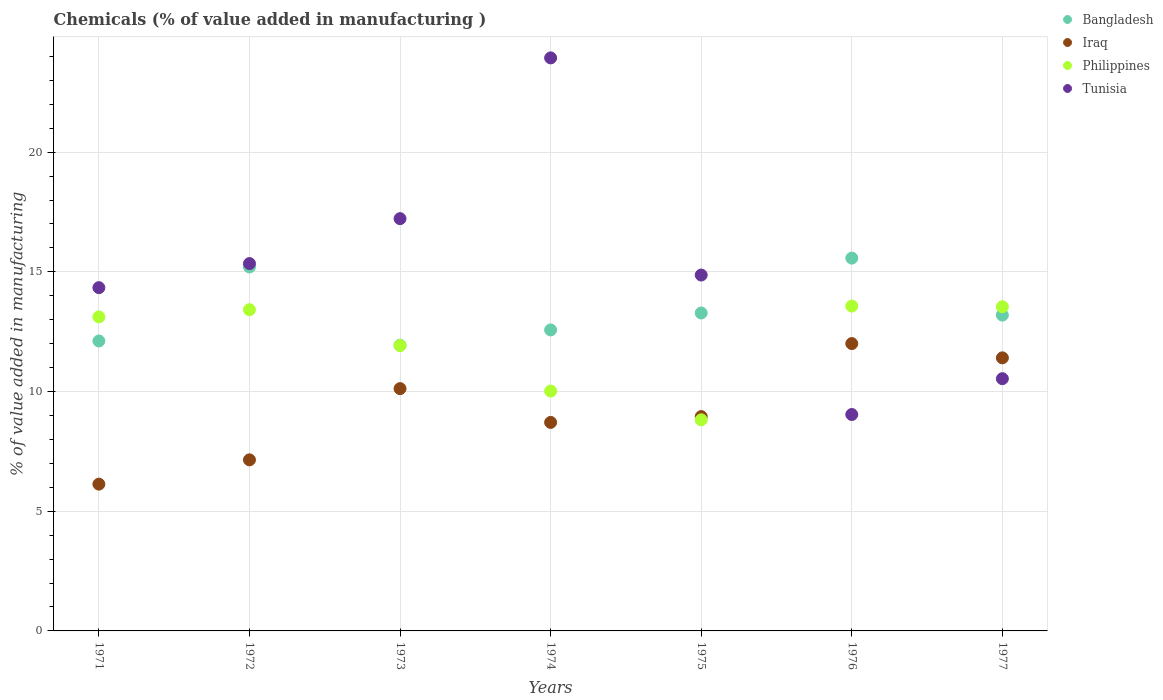How many different coloured dotlines are there?
Your answer should be compact. 4. Is the number of dotlines equal to the number of legend labels?
Your answer should be compact. Yes. What is the value added in manufacturing chemicals in Tunisia in 1972?
Offer a very short reply. 15.35. Across all years, what is the maximum value added in manufacturing chemicals in Bangladesh?
Keep it short and to the point. 15.57. Across all years, what is the minimum value added in manufacturing chemicals in Bangladesh?
Ensure brevity in your answer.  11.93. In which year was the value added in manufacturing chemicals in Philippines maximum?
Offer a terse response. 1976. In which year was the value added in manufacturing chemicals in Tunisia minimum?
Ensure brevity in your answer.  1976. What is the total value added in manufacturing chemicals in Philippines in the graph?
Provide a succinct answer. 84.41. What is the difference between the value added in manufacturing chemicals in Philippines in 1974 and that in 1975?
Keep it short and to the point. 1.2. What is the difference between the value added in manufacturing chemicals in Bangladesh in 1973 and the value added in manufacturing chemicals in Philippines in 1971?
Make the answer very short. -1.18. What is the average value added in manufacturing chemicals in Philippines per year?
Offer a very short reply. 12.06. In the year 1976, what is the difference between the value added in manufacturing chemicals in Iraq and value added in manufacturing chemicals in Philippines?
Make the answer very short. -1.57. In how many years, is the value added in manufacturing chemicals in Bangladesh greater than 16 %?
Make the answer very short. 0. What is the ratio of the value added in manufacturing chemicals in Iraq in 1973 to that in 1975?
Your response must be concise. 1.13. Is the value added in manufacturing chemicals in Bangladesh in 1975 less than that in 1976?
Your answer should be compact. Yes. Is the difference between the value added in manufacturing chemicals in Iraq in 1971 and 1972 greater than the difference between the value added in manufacturing chemicals in Philippines in 1971 and 1972?
Keep it short and to the point. No. What is the difference between the highest and the second highest value added in manufacturing chemicals in Bangladesh?
Offer a terse response. 0.37. What is the difference between the highest and the lowest value added in manufacturing chemicals in Iraq?
Offer a terse response. 5.87. Is it the case that in every year, the sum of the value added in manufacturing chemicals in Tunisia and value added in manufacturing chemicals in Bangladesh  is greater than the sum of value added in manufacturing chemicals in Philippines and value added in manufacturing chemicals in Iraq?
Your answer should be compact. No. Is it the case that in every year, the sum of the value added in manufacturing chemicals in Iraq and value added in manufacturing chemicals in Tunisia  is greater than the value added in manufacturing chemicals in Philippines?
Make the answer very short. Yes. Does the value added in manufacturing chemicals in Philippines monotonically increase over the years?
Your answer should be compact. No. How many dotlines are there?
Ensure brevity in your answer.  4. How many years are there in the graph?
Make the answer very short. 7. Are the values on the major ticks of Y-axis written in scientific E-notation?
Your response must be concise. No. Does the graph contain grids?
Provide a short and direct response. Yes. What is the title of the graph?
Give a very brief answer. Chemicals (% of value added in manufacturing ). Does "Tanzania" appear as one of the legend labels in the graph?
Make the answer very short. No. What is the label or title of the Y-axis?
Your answer should be very brief. % of value added in manufacturing. What is the % of value added in manufacturing of Bangladesh in 1971?
Ensure brevity in your answer.  12.11. What is the % of value added in manufacturing of Iraq in 1971?
Ensure brevity in your answer.  6.13. What is the % of value added in manufacturing in Philippines in 1971?
Your answer should be compact. 13.12. What is the % of value added in manufacturing in Tunisia in 1971?
Your answer should be very brief. 14.34. What is the % of value added in manufacturing in Bangladesh in 1972?
Your answer should be compact. 15.2. What is the % of value added in manufacturing in Iraq in 1972?
Ensure brevity in your answer.  7.15. What is the % of value added in manufacturing in Philippines in 1972?
Offer a terse response. 13.42. What is the % of value added in manufacturing in Tunisia in 1972?
Offer a very short reply. 15.35. What is the % of value added in manufacturing in Bangladesh in 1973?
Offer a very short reply. 11.93. What is the % of value added in manufacturing of Iraq in 1973?
Provide a short and direct response. 10.12. What is the % of value added in manufacturing in Philippines in 1973?
Ensure brevity in your answer.  11.92. What is the % of value added in manufacturing of Tunisia in 1973?
Provide a succinct answer. 17.22. What is the % of value added in manufacturing in Bangladesh in 1974?
Ensure brevity in your answer.  12.57. What is the % of value added in manufacturing in Iraq in 1974?
Make the answer very short. 8.71. What is the % of value added in manufacturing of Philippines in 1974?
Ensure brevity in your answer.  10.02. What is the % of value added in manufacturing in Tunisia in 1974?
Keep it short and to the point. 23.94. What is the % of value added in manufacturing in Bangladesh in 1975?
Provide a short and direct response. 13.28. What is the % of value added in manufacturing in Iraq in 1975?
Your response must be concise. 8.95. What is the % of value added in manufacturing of Philippines in 1975?
Give a very brief answer. 8.82. What is the % of value added in manufacturing in Tunisia in 1975?
Keep it short and to the point. 14.87. What is the % of value added in manufacturing of Bangladesh in 1976?
Offer a very short reply. 15.57. What is the % of value added in manufacturing of Iraq in 1976?
Your answer should be very brief. 12. What is the % of value added in manufacturing in Philippines in 1976?
Make the answer very short. 13.57. What is the % of value added in manufacturing of Tunisia in 1976?
Your answer should be very brief. 9.04. What is the % of value added in manufacturing of Bangladesh in 1977?
Provide a short and direct response. 13.19. What is the % of value added in manufacturing in Iraq in 1977?
Your response must be concise. 11.41. What is the % of value added in manufacturing in Philippines in 1977?
Your answer should be very brief. 13.54. What is the % of value added in manufacturing in Tunisia in 1977?
Your answer should be compact. 10.54. Across all years, what is the maximum % of value added in manufacturing of Bangladesh?
Your answer should be very brief. 15.57. Across all years, what is the maximum % of value added in manufacturing of Iraq?
Give a very brief answer. 12. Across all years, what is the maximum % of value added in manufacturing of Philippines?
Provide a succinct answer. 13.57. Across all years, what is the maximum % of value added in manufacturing in Tunisia?
Give a very brief answer. 23.94. Across all years, what is the minimum % of value added in manufacturing of Bangladesh?
Give a very brief answer. 11.93. Across all years, what is the minimum % of value added in manufacturing in Iraq?
Your response must be concise. 6.13. Across all years, what is the minimum % of value added in manufacturing in Philippines?
Offer a very short reply. 8.82. Across all years, what is the minimum % of value added in manufacturing of Tunisia?
Your answer should be very brief. 9.04. What is the total % of value added in manufacturing of Bangladesh in the graph?
Make the answer very short. 93.88. What is the total % of value added in manufacturing in Iraq in the graph?
Your answer should be compact. 64.48. What is the total % of value added in manufacturing of Philippines in the graph?
Provide a succinct answer. 84.41. What is the total % of value added in manufacturing in Tunisia in the graph?
Offer a terse response. 105.29. What is the difference between the % of value added in manufacturing in Bangladesh in 1971 and that in 1972?
Your answer should be compact. -3.09. What is the difference between the % of value added in manufacturing in Iraq in 1971 and that in 1972?
Offer a very short reply. -1.01. What is the difference between the % of value added in manufacturing of Philippines in 1971 and that in 1972?
Ensure brevity in your answer.  -0.3. What is the difference between the % of value added in manufacturing in Tunisia in 1971 and that in 1972?
Give a very brief answer. -1.01. What is the difference between the % of value added in manufacturing in Bangladesh in 1971 and that in 1973?
Your answer should be compact. 0.18. What is the difference between the % of value added in manufacturing of Iraq in 1971 and that in 1973?
Your response must be concise. -3.99. What is the difference between the % of value added in manufacturing of Philippines in 1971 and that in 1973?
Your answer should be compact. 1.2. What is the difference between the % of value added in manufacturing in Tunisia in 1971 and that in 1973?
Your answer should be compact. -2.88. What is the difference between the % of value added in manufacturing of Bangladesh in 1971 and that in 1974?
Your response must be concise. -0.46. What is the difference between the % of value added in manufacturing in Iraq in 1971 and that in 1974?
Make the answer very short. -2.58. What is the difference between the % of value added in manufacturing of Philippines in 1971 and that in 1974?
Offer a very short reply. 3.1. What is the difference between the % of value added in manufacturing of Tunisia in 1971 and that in 1974?
Make the answer very short. -9.6. What is the difference between the % of value added in manufacturing of Bangladesh in 1971 and that in 1975?
Provide a short and direct response. -1.17. What is the difference between the % of value added in manufacturing in Iraq in 1971 and that in 1975?
Keep it short and to the point. -2.82. What is the difference between the % of value added in manufacturing of Philippines in 1971 and that in 1975?
Offer a very short reply. 4.3. What is the difference between the % of value added in manufacturing of Tunisia in 1971 and that in 1975?
Keep it short and to the point. -0.53. What is the difference between the % of value added in manufacturing of Bangladesh in 1971 and that in 1976?
Your answer should be very brief. -3.46. What is the difference between the % of value added in manufacturing of Iraq in 1971 and that in 1976?
Provide a short and direct response. -5.87. What is the difference between the % of value added in manufacturing of Philippines in 1971 and that in 1976?
Provide a short and direct response. -0.45. What is the difference between the % of value added in manufacturing in Tunisia in 1971 and that in 1976?
Offer a terse response. 5.3. What is the difference between the % of value added in manufacturing of Bangladesh in 1971 and that in 1977?
Your response must be concise. -1.08. What is the difference between the % of value added in manufacturing of Iraq in 1971 and that in 1977?
Your answer should be very brief. -5.28. What is the difference between the % of value added in manufacturing in Philippines in 1971 and that in 1977?
Make the answer very short. -0.42. What is the difference between the % of value added in manufacturing of Tunisia in 1971 and that in 1977?
Give a very brief answer. 3.8. What is the difference between the % of value added in manufacturing of Bangladesh in 1972 and that in 1973?
Ensure brevity in your answer.  3.27. What is the difference between the % of value added in manufacturing of Iraq in 1972 and that in 1973?
Provide a short and direct response. -2.98. What is the difference between the % of value added in manufacturing in Philippines in 1972 and that in 1973?
Provide a short and direct response. 1.5. What is the difference between the % of value added in manufacturing of Tunisia in 1972 and that in 1973?
Provide a short and direct response. -1.88. What is the difference between the % of value added in manufacturing of Bangladesh in 1972 and that in 1974?
Keep it short and to the point. 2.63. What is the difference between the % of value added in manufacturing of Iraq in 1972 and that in 1974?
Keep it short and to the point. -1.56. What is the difference between the % of value added in manufacturing in Philippines in 1972 and that in 1974?
Provide a short and direct response. 3.4. What is the difference between the % of value added in manufacturing in Tunisia in 1972 and that in 1974?
Give a very brief answer. -8.59. What is the difference between the % of value added in manufacturing in Bangladesh in 1972 and that in 1975?
Your answer should be compact. 1.92. What is the difference between the % of value added in manufacturing in Iraq in 1972 and that in 1975?
Ensure brevity in your answer.  -1.81. What is the difference between the % of value added in manufacturing in Philippines in 1972 and that in 1975?
Your answer should be very brief. 4.6. What is the difference between the % of value added in manufacturing in Tunisia in 1972 and that in 1975?
Ensure brevity in your answer.  0.48. What is the difference between the % of value added in manufacturing in Bangladesh in 1972 and that in 1976?
Your answer should be very brief. -0.37. What is the difference between the % of value added in manufacturing of Iraq in 1972 and that in 1976?
Offer a terse response. -4.86. What is the difference between the % of value added in manufacturing of Philippines in 1972 and that in 1976?
Provide a succinct answer. -0.15. What is the difference between the % of value added in manufacturing in Tunisia in 1972 and that in 1976?
Offer a very short reply. 6.31. What is the difference between the % of value added in manufacturing of Bangladesh in 1972 and that in 1977?
Make the answer very short. 2.01. What is the difference between the % of value added in manufacturing in Iraq in 1972 and that in 1977?
Offer a terse response. -4.26. What is the difference between the % of value added in manufacturing in Philippines in 1972 and that in 1977?
Your answer should be compact. -0.12. What is the difference between the % of value added in manufacturing in Tunisia in 1972 and that in 1977?
Offer a terse response. 4.81. What is the difference between the % of value added in manufacturing of Bangladesh in 1973 and that in 1974?
Offer a very short reply. -0.64. What is the difference between the % of value added in manufacturing in Iraq in 1973 and that in 1974?
Your response must be concise. 1.41. What is the difference between the % of value added in manufacturing in Philippines in 1973 and that in 1974?
Make the answer very short. 1.9. What is the difference between the % of value added in manufacturing of Tunisia in 1973 and that in 1974?
Provide a short and direct response. -6.72. What is the difference between the % of value added in manufacturing in Bangladesh in 1973 and that in 1975?
Your answer should be very brief. -1.35. What is the difference between the % of value added in manufacturing in Iraq in 1973 and that in 1975?
Offer a very short reply. 1.17. What is the difference between the % of value added in manufacturing of Philippines in 1973 and that in 1975?
Provide a succinct answer. 3.1. What is the difference between the % of value added in manufacturing of Tunisia in 1973 and that in 1975?
Make the answer very short. 2.36. What is the difference between the % of value added in manufacturing in Bangladesh in 1973 and that in 1976?
Provide a succinct answer. -3.64. What is the difference between the % of value added in manufacturing in Iraq in 1973 and that in 1976?
Give a very brief answer. -1.88. What is the difference between the % of value added in manufacturing in Philippines in 1973 and that in 1976?
Keep it short and to the point. -1.65. What is the difference between the % of value added in manufacturing of Tunisia in 1973 and that in 1976?
Ensure brevity in your answer.  8.18. What is the difference between the % of value added in manufacturing of Bangladesh in 1973 and that in 1977?
Offer a very short reply. -1.26. What is the difference between the % of value added in manufacturing in Iraq in 1973 and that in 1977?
Your response must be concise. -1.29. What is the difference between the % of value added in manufacturing of Philippines in 1973 and that in 1977?
Your answer should be compact. -1.62. What is the difference between the % of value added in manufacturing in Tunisia in 1973 and that in 1977?
Your answer should be compact. 6.69. What is the difference between the % of value added in manufacturing of Bangladesh in 1974 and that in 1975?
Your answer should be compact. -0.71. What is the difference between the % of value added in manufacturing of Iraq in 1974 and that in 1975?
Ensure brevity in your answer.  -0.24. What is the difference between the % of value added in manufacturing in Philippines in 1974 and that in 1975?
Provide a succinct answer. 1.2. What is the difference between the % of value added in manufacturing in Tunisia in 1974 and that in 1975?
Give a very brief answer. 9.07. What is the difference between the % of value added in manufacturing in Bangladesh in 1974 and that in 1976?
Make the answer very short. -3. What is the difference between the % of value added in manufacturing in Iraq in 1974 and that in 1976?
Offer a very short reply. -3.29. What is the difference between the % of value added in manufacturing in Philippines in 1974 and that in 1976?
Your answer should be compact. -3.55. What is the difference between the % of value added in manufacturing of Tunisia in 1974 and that in 1976?
Ensure brevity in your answer.  14.9. What is the difference between the % of value added in manufacturing of Bangladesh in 1974 and that in 1977?
Keep it short and to the point. -0.62. What is the difference between the % of value added in manufacturing of Iraq in 1974 and that in 1977?
Provide a succinct answer. -2.7. What is the difference between the % of value added in manufacturing in Philippines in 1974 and that in 1977?
Keep it short and to the point. -3.52. What is the difference between the % of value added in manufacturing in Tunisia in 1974 and that in 1977?
Provide a succinct answer. 13.4. What is the difference between the % of value added in manufacturing in Bangladesh in 1975 and that in 1976?
Give a very brief answer. -2.29. What is the difference between the % of value added in manufacturing of Iraq in 1975 and that in 1976?
Ensure brevity in your answer.  -3.05. What is the difference between the % of value added in manufacturing of Philippines in 1975 and that in 1976?
Provide a short and direct response. -4.75. What is the difference between the % of value added in manufacturing of Tunisia in 1975 and that in 1976?
Offer a very short reply. 5.83. What is the difference between the % of value added in manufacturing in Bangladesh in 1975 and that in 1977?
Offer a very short reply. 0.09. What is the difference between the % of value added in manufacturing in Iraq in 1975 and that in 1977?
Provide a succinct answer. -2.45. What is the difference between the % of value added in manufacturing of Philippines in 1975 and that in 1977?
Keep it short and to the point. -4.72. What is the difference between the % of value added in manufacturing of Tunisia in 1975 and that in 1977?
Keep it short and to the point. 4.33. What is the difference between the % of value added in manufacturing in Bangladesh in 1976 and that in 1977?
Your response must be concise. 2.38. What is the difference between the % of value added in manufacturing in Iraq in 1976 and that in 1977?
Ensure brevity in your answer.  0.6. What is the difference between the % of value added in manufacturing in Philippines in 1976 and that in 1977?
Your answer should be very brief. 0.03. What is the difference between the % of value added in manufacturing of Tunisia in 1976 and that in 1977?
Ensure brevity in your answer.  -1.5. What is the difference between the % of value added in manufacturing of Bangladesh in 1971 and the % of value added in manufacturing of Iraq in 1972?
Your response must be concise. 4.97. What is the difference between the % of value added in manufacturing in Bangladesh in 1971 and the % of value added in manufacturing in Philippines in 1972?
Make the answer very short. -1.31. What is the difference between the % of value added in manufacturing in Bangladesh in 1971 and the % of value added in manufacturing in Tunisia in 1972?
Your response must be concise. -3.24. What is the difference between the % of value added in manufacturing in Iraq in 1971 and the % of value added in manufacturing in Philippines in 1972?
Provide a short and direct response. -7.29. What is the difference between the % of value added in manufacturing of Iraq in 1971 and the % of value added in manufacturing of Tunisia in 1972?
Your answer should be compact. -9.22. What is the difference between the % of value added in manufacturing in Philippines in 1971 and the % of value added in manufacturing in Tunisia in 1972?
Your answer should be very brief. -2.23. What is the difference between the % of value added in manufacturing of Bangladesh in 1971 and the % of value added in manufacturing of Iraq in 1973?
Keep it short and to the point. 1.99. What is the difference between the % of value added in manufacturing of Bangladesh in 1971 and the % of value added in manufacturing of Philippines in 1973?
Ensure brevity in your answer.  0.19. What is the difference between the % of value added in manufacturing in Bangladesh in 1971 and the % of value added in manufacturing in Tunisia in 1973?
Ensure brevity in your answer.  -5.11. What is the difference between the % of value added in manufacturing of Iraq in 1971 and the % of value added in manufacturing of Philippines in 1973?
Make the answer very short. -5.79. What is the difference between the % of value added in manufacturing of Iraq in 1971 and the % of value added in manufacturing of Tunisia in 1973?
Offer a very short reply. -11.09. What is the difference between the % of value added in manufacturing of Philippines in 1971 and the % of value added in manufacturing of Tunisia in 1973?
Give a very brief answer. -4.1. What is the difference between the % of value added in manufacturing in Bangladesh in 1971 and the % of value added in manufacturing in Iraq in 1974?
Your answer should be very brief. 3.4. What is the difference between the % of value added in manufacturing of Bangladesh in 1971 and the % of value added in manufacturing of Philippines in 1974?
Offer a very short reply. 2.09. What is the difference between the % of value added in manufacturing of Bangladesh in 1971 and the % of value added in manufacturing of Tunisia in 1974?
Make the answer very short. -11.83. What is the difference between the % of value added in manufacturing of Iraq in 1971 and the % of value added in manufacturing of Philippines in 1974?
Your answer should be compact. -3.89. What is the difference between the % of value added in manufacturing in Iraq in 1971 and the % of value added in manufacturing in Tunisia in 1974?
Your response must be concise. -17.81. What is the difference between the % of value added in manufacturing of Philippines in 1971 and the % of value added in manufacturing of Tunisia in 1974?
Your answer should be compact. -10.82. What is the difference between the % of value added in manufacturing of Bangladesh in 1971 and the % of value added in manufacturing of Iraq in 1975?
Offer a terse response. 3.16. What is the difference between the % of value added in manufacturing in Bangladesh in 1971 and the % of value added in manufacturing in Philippines in 1975?
Offer a very short reply. 3.29. What is the difference between the % of value added in manufacturing of Bangladesh in 1971 and the % of value added in manufacturing of Tunisia in 1975?
Your response must be concise. -2.75. What is the difference between the % of value added in manufacturing of Iraq in 1971 and the % of value added in manufacturing of Philippines in 1975?
Your answer should be very brief. -2.69. What is the difference between the % of value added in manufacturing of Iraq in 1971 and the % of value added in manufacturing of Tunisia in 1975?
Provide a short and direct response. -8.73. What is the difference between the % of value added in manufacturing in Philippines in 1971 and the % of value added in manufacturing in Tunisia in 1975?
Your answer should be very brief. -1.75. What is the difference between the % of value added in manufacturing in Bangladesh in 1971 and the % of value added in manufacturing in Iraq in 1976?
Your response must be concise. 0.11. What is the difference between the % of value added in manufacturing of Bangladesh in 1971 and the % of value added in manufacturing of Philippines in 1976?
Make the answer very short. -1.46. What is the difference between the % of value added in manufacturing in Bangladesh in 1971 and the % of value added in manufacturing in Tunisia in 1976?
Ensure brevity in your answer.  3.07. What is the difference between the % of value added in manufacturing of Iraq in 1971 and the % of value added in manufacturing of Philippines in 1976?
Your response must be concise. -7.44. What is the difference between the % of value added in manufacturing of Iraq in 1971 and the % of value added in manufacturing of Tunisia in 1976?
Provide a short and direct response. -2.91. What is the difference between the % of value added in manufacturing of Philippines in 1971 and the % of value added in manufacturing of Tunisia in 1976?
Provide a succinct answer. 4.08. What is the difference between the % of value added in manufacturing in Bangladesh in 1971 and the % of value added in manufacturing in Iraq in 1977?
Give a very brief answer. 0.7. What is the difference between the % of value added in manufacturing in Bangladesh in 1971 and the % of value added in manufacturing in Philippines in 1977?
Your response must be concise. -1.43. What is the difference between the % of value added in manufacturing of Bangladesh in 1971 and the % of value added in manufacturing of Tunisia in 1977?
Offer a terse response. 1.58. What is the difference between the % of value added in manufacturing of Iraq in 1971 and the % of value added in manufacturing of Philippines in 1977?
Give a very brief answer. -7.41. What is the difference between the % of value added in manufacturing of Iraq in 1971 and the % of value added in manufacturing of Tunisia in 1977?
Your response must be concise. -4.4. What is the difference between the % of value added in manufacturing in Philippines in 1971 and the % of value added in manufacturing in Tunisia in 1977?
Make the answer very short. 2.58. What is the difference between the % of value added in manufacturing in Bangladesh in 1972 and the % of value added in manufacturing in Iraq in 1973?
Ensure brevity in your answer.  5.08. What is the difference between the % of value added in manufacturing of Bangladesh in 1972 and the % of value added in manufacturing of Philippines in 1973?
Give a very brief answer. 3.29. What is the difference between the % of value added in manufacturing in Bangladesh in 1972 and the % of value added in manufacturing in Tunisia in 1973?
Your answer should be very brief. -2.02. What is the difference between the % of value added in manufacturing in Iraq in 1972 and the % of value added in manufacturing in Philippines in 1973?
Keep it short and to the point. -4.77. What is the difference between the % of value added in manufacturing of Iraq in 1972 and the % of value added in manufacturing of Tunisia in 1973?
Provide a succinct answer. -10.08. What is the difference between the % of value added in manufacturing of Philippines in 1972 and the % of value added in manufacturing of Tunisia in 1973?
Keep it short and to the point. -3.8. What is the difference between the % of value added in manufacturing of Bangladesh in 1972 and the % of value added in manufacturing of Iraq in 1974?
Keep it short and to the point. 6.49. What is the difference between the % of value added in manufacturing in Bangladesh in 1972 and the % of value added in manufacturing in Philippines in 1974?
Provide a succinct answer. 5.18. What is the difference between the % of value added in manufacturing in Bangladesh in 1972 and the % of value added in manufacturing in Tunisia in 1974?
Give a very brief answer. -8.73. What is the difference between the % of value added in manufacturing of Iraq in 1972 and the % of value added in manufacturing of Philippines in 1974?
Your answer should be compact. -2.87. What is the difference between the % of value added in manufacturing of Iraq in 1972 and the % of value added in manufacturing of Tunisia in 1974?
Your answer should be compact. -16.79. What is the difference between the % of value added in manufacturing of Philippines in 1972 and the % of value added in manufacturing of Tunisia in 1974?
Give a very brief answer. -10.52. What is the difference between the % of value added in manufacturing of Bangladesh in 1972 and the % of value added in manufacturing of Iraq in 1975?
Your answer should be very brief. 6.25. What is the difference between the % of value added in manufacturing in Bangladesh in 1972 and the % of value added in manufacturing in Philippines in 1975?
Provide a succinct answer. 6.39. What is the difference between the % of value added in manufacturing in Bangladesh in 1972 and the % of value added in manufacturing in Tunisia in 1975?
Provide a short and direct response. 0.34. What is the difference between the % of value added in manufacturing in Iraq in 1972 and the % of value added in manufacturing in Philippines in 1975?
Your answer should be compact. -1.67. What is the difference between the % of value added in manufacturing in Iraq in 1972 and the % of value added in manufacturing in Tunisia in 1975?
Your response must be concise. -7.72. What is the difference between the % of value added in manufacturing of Philippines in 1972 and the % of value added in manufacturing of Tunisia in 1975?
Your answer should be compact. -1.45. What is the difference between the % of value added in manufacturing in Bangladesh in 1972 and the % of value added in manufacturing in Iraq in 1976?
Make the answer very short. 3.2. What is the difference between the % of value added in manufacturing in Bangladesh in 1972 and the % of value added in manufacturing in Philippines in 1976?
Give a very brief answer. 1.63. What is the difference between the % of value added in manufacturing in Bangladesh in 1972 and the % of value added in manufacturing in Tunisia in 1976?
Give a very brief answer. 6.16. What is the difference between the % of value added in manufacturing of Iraq in 1972 and the % of value added in manufacturing of Philippines in 1976?
Offer a very short reply. -6.42. What is the difference between the % of value added in manufacturing of Iraq in 1972 and the % of value added in manufacturing of Tunisia in 1976?
Provide a succinct answer. -1.89. What is the difference between the % of value added in manufacturing in Philippines in 1972 and the % of value added in manufacturing in Tunisia in 1976?
Keep it short and to the point. 4.38. What is the difference between the % of value added in manufacturing in Bangladesh in 1972 and the % of value added in manufacturing in Iraq in 1977?
Provide a short and direct response. 3.8. What is the difference between the % of value added in manufacturing in Bangladesh in 1972 and the % of value added in manufacturing in Philippines in 1977?
Give a very brief answer. 1.66. What is the difference between the % of value added in manufacturing in Bangladesh in 1972 and the % of value added in manufacturing in Tunisia in 1977?
Your answer should be very brief. 4.67. What is the difference between the % of value added in manufacturing in Iraq in 1972 and the % of value added in manufacturing in Philippines in 1977?
Provide a succinct answer. -6.4. What is the difference between the % of value added in manufacturing in Iraq in 1972 and the % of value added in manufacturing in Tunisia in 1977?
Ensure brevity in your answer.  -3.39. What is the difference between the % of value added in manufacturing of Philippines in 1972 and the % of value added in manufacturing of Tunisia in 1977?
Provide a short and direct response. 2.88. What is the difference between the % of value added in manufacturing of Bangladesh in 1973 and the % of value added in manufacturing of Iraq in 1974?
Give a very brief answer. 3.22. What is the difference between the % of value added in manufacturing of Bangladesh in 1973 and the % of value added in manufacturing of Philippines in 1974?
Your answer should be compact. 1.91. What is the difference between the % of value added in manufacturing of Bangladesh in 1973 and the % of value added in manufacturing of Tunisia in 1974?
Your response must be concise. -12. What is the difference between the % of value added in manufacturing of Iraq in 1973 and the % of value added in manufacturing of Philippines in 1974?
Offer a terse response. 0.1. What is the difference between the % of value added in manufacturing in Iraq in 1973 and the % of value added in manufacturing in Tunisia in 1974?
Keep it short and to the point. -13.82. What is the difference between the % of value added in manufacturing in Philippines in 1973 and the % of value added in manufacturing in Tunisia in 1974?
Make the answer very short. -12.02. What is the difference between the % of value added in manufacturing in Bangladesh in 1973 and the % of value added in manufacturing in Iraq in 1975?
Provide a short and direct response. 2.98. What is the difference between the % of value added in manufacturing of Bangladesh in 1973 and the % of value added in manufacturing of Philippines in 1975?
Provide a succinct answer. 3.12. What is the difference between the % of value added in manufacturing in Bangladesh in 1973 and the % of value added in manufacturing in Tunisia in 1975?
Ensure brevity in your answer.  -2.93. What is the difference between the % of value added in manufacturing in Iraq in 1973 and the % of value added in manufacturing in Philippines in 1975?
Ensure brevity in your answer.  1.3. What is the difference between the % of value added in manufacturing of Iraq in 1973 and the % of value added in manufacturing of Tunisia in 1975?
Give a very brief answer. -4.74. What is the difference between the % of value added in manufacturing in Philippines in 1973 and the % of value added in manufacturing in Tunisia in 1975?
Your answer should be compact. -2.95. What is the difference between the % of value added in manufacturing in Bangladesh in 1973 and the % of value added in manufacturing in Iraq in 1976?
Offer a very short reply. -0.07. What is the difference between the % of value added in manufacturing in Bangladesh in 1973 and the % of value added in manufacturing in Philippines in 1976?
Give a very brief answer. -1.64. What is the difference between the % of value added in manufacturing of Bangladesh in 1973 and the % of value added in manufacturing of Tunisia in 1976?
Your answer should be compact. 2.89. What is the difference between the % of value added in manufacturing of Iraq in 1973 and the % of value added in manufacturing of Philippines in 1976?
Keep it short and to the point. -3.45. What is the difference between the % of value added in manufacturing in Iraq in 1973 and the % of value added in manufacturing in Tunisia in 1976?
Your answer should be very brief. 1.08. What is the difference between the % of value added in manufacturing in Philippines in 1973 and the % of value added in manufacturing in Tunisia in 1976?
Your answer should be compact. 2.88. What is the difference between the % of value added in manufacturing of Bangladesh in 1973 and the % of value added in manufacturing of Iraq in 1977?
Make the answer very short. 0.53. What is the difference between the % of value added in manufacturing of Bangladesh in 1973 and the % of value added in manufacturing of Philippines in 1977?
Offer a very short reply. -1.61. What is the difference between the % of value added in manufacturing of Bangladesh in 1973 and the % of value added in manufacturing of Tunisia in 1977?
Offer a very short reply. 1.4. What is the difference between the % of value added in manufacturing of Iraq in 1973 and the % of value added in manufacturing of Philippines in 1977?
Offer a terse response. -3.42. What is the difference between the % of value added in manufacturing of Iraq in 1973 and the % of value added in manufacturing of Tunisia in 1977?
Make the answer very short. -0.41. What is the difference between the % of value added in manufacturing in Philippines in 1973 and the % of value added in manufacturing in Tunisia in 1977?
Your answer should be compact. 1.38. What is the difference between the % of value added in manufacturing of Bangladesh in 1974 and the % of value added in manufacturing of Iraq in 1975?
Your response must be concise. 3.62. What is the difference between the % of value added in manufacturing of Bangladesh in 1974 and the % of value added in manufacturing of Philippines in 1975?
Ensure brevity in your answer.  3.76. What is the difference between the % of value added in manufacturing of Bangladesh in 1974 and the % of value added in manufacturing of Tunisia in 1975?
Ensure brevity in your answer.  -2.29. What is the difference between the % of value added in manufacturing of Iraq in 1974 and the % of value added in manufacturing of Philippines in 1975?
Your response must be concise. -0.11. What is the difference between the % of value added in manufacturing in Iraq in 1974 and the % of value added in manufacturing in Tunisia in 1975?
Your answer should be very brief. -6.16. What is the difference between the % of value added in manufacturing of Philippines in 1974 and the % of value added in manufacturing of Tunisia in 1975?
Offer a terse response. -4.85. What is the difference between the % of value added in manufacturing in Bangladesh in 1974 and the % of value added in manufacturing in Iraq in 1976?
Your answer should be very brief. 0.57. What is the difference between the % of value added in manufacturing in Bangladesh in 1974 and the % of value added in manufacturing in Philippines in 1976?
Your answer should be very brief. -1. What is the difference between the % of value added in manufacturing in Bangladesh in 1974 and the % of value added in manufacturing in Tunisia in 1976?
Make the answer very short. 3.53. What is the difference between the % of value added in manufacturing of Iraq in 1974 and the % of value added in manufacturing of Philippines in 1976?
Ensure brevity in your answer.  -4.86. What is the difference between the % of value added in manufacturing of Iraq in 1974 and the % of value added in manufacturing of Tunisia in 1976?
Provide a succinct answer. -0.33. What is the difference between the % of value added in manufacturing in Philippines in 1974 and the % of value added in manufacturing in Tunisia in 1976?
Your answer should be compact. 0.98. What is the difference between the % of value added in manufacturing in Bangladesh in 1974 and the % of value added in manufacturing in Iraq in 1977?
Offer a very short reply. 1.17. What is the difference between the % of value added in manufacturing of Bangladesh in 1974 and the % of value added in manufacturing of Philippines in 1977?
Offer a very short reply. -0.97. What is the difference between the % of value added in manufacturing of Bangladesh in 1974 and the % of value added in manufacturing of Tunisia in 1977?
Offer a very short reply. 2.04. What is the difference between the % of value added in manufacturing in Iraq in 1974 and the % of value added in manufacturing in Philippines in 1977?
Make the answer very short. -4.83. What is the difference between the % of value added in manufacturing in Iraq in 1974 and the % of value added in manufacturing in Tunisia in 1977?
Give a very brief answer. -1.83. What is the difference between the % of value added in manufacturing of Philippines in 1974 and the % of value added in manufacturing of Tunisia in 1977?
Give a very brief answer. -0.52. What is the difference between the % of value added in manufacturing of Bangladesh in 1975 and the % of value added in manufacturing of Iraq in 1976?
Offer a very short reply. 1.28. What is the difference between the % of value added in manufacturing in Bangladesh in 1975 and the % of value added in manufacturing in Philippines in 1976?
Provide a short and direct response. -0.29. What is the difference between the % of value added in manufacturing of Bangladesh in 1975 and the % of value added in manufacturing of Tunisia in 1976?
Make the answer very short. 4.24. What is the difference between the % of value added in manufacturing in Iraq in 1975 and the % of value added in manufacturing in Philippines in 1976?
Offer a terse response. -4.62. What is the difference between the % of value added in manufacturing in Iraq in 1975 and the % of value added in manufacturing in Tunisia in 1976?
Offer a terse response. -0.09. What is the difference between the % of value added in manufacturing of Philippines in 1975 and the % of value added in manufacturing of Tunisia in 1976?
Offer a terse response. -0.22. What is the difference between the % of value added in manufacturing in Bangladesh in 1975 and the % of value added in manufacturing in Iraq in 1977?
Your response must be concise. 1.87. What is the difference between the % of value added in manufacturing in Bangladesh in 1975 and the % of value added in manufacturing in Philippines in 1977?
Offer a very short reply. -0.26. What is the difference between the % of value added in manufacturing in Bangladesh in 1975 and the % of value added in manufacturing in Tunisia in 1977?
Offer a terse response. 2.74. What is the difference between the % of value added in manufacturing in Iraq in 1975 and the % of value added in manufacturing in Philippines in 1977?
Ensure brevity in your answer.  -4.59. What is the difference between the % of value added in manufacturing of Iraq in 1975 and the % of value added in manufacturing of Tunisia in 1977?
Offer a terse response. -1.58. What is the difference between the % of value added in manufacturing of Philippines in 1975 and the % of value added in manufacturing of Tunisia in 1977?
Offer a terse response. -1.72. What is the difference between the % of value added in manufacturing in Bangladesh in 1976 and the % of value added in manufacturing in Iraq in 1977?
Ensure brevity in your answer.  4.17. What is the difference between the % of value added in manufacturing of Bangladesh in 1976 and the % of value added in manufacturing of Philippines in 1977?
Offer a terse response. 2.03. What is the difference between the % of value added in manufacturing of Bangladesh in 1976 and the % of value added in manufacturing of Tunisia in 1977?
Provide a succinct answer. 5.04. What is the difference between the % of value added in manufacturing in Iraq in 1976 and the % of value added in manufacturing in Philippines in 1977?
Ensure brevity in your answer.  -1.54. What is the difference between the % of value added in manufacturing of Iraq in 1976 and the % of value added in manufacturing of Tunisia in 1977?
Provide a succinct answer. 1.47. What is the difference between the % of value added in manufacturing of Philippines in 1976 and the % of value added in manufacturing of Tunisia in 1977?
Offer a terse response. 3.03. What is the average % of value added in manufacturing in Bangladesh per year?
Ensure brevity in your answer.  13.41. What is the average % of value added in manufacturing in Iraq per year?
Offer a terse response. 9.21. What is the average % of value added in manufacturing of Philippines per year?
Keep it short and to the point. 12.06. What is the average % of value added in manufacturing in Tunisia per year?
Ensure brevity in your answer.  15.04. In the year 1971, what is the difference between the % of value added in manufacturing of Bangladesh and % of value added in manufacturing of Iraq?
Give a very brief answer. 5.98. In the year 1971, what is the difference between the % of value added in manufacturing of Bangladesh and % of value added in manufacturing of Philippines?
Provide a short and direct response. -1.01. In the year 1971, what is the difference between the % of value added in manufacturing in Bangladesh and % of value added in manufacturing in Tunisia?
Offer a very short reply. -2.23. In the year 1971, what is the difference between the % of value added in manufacturing of Iraq and % of value added in manufacturing of Philippines?
Your answer should be very brief. -6.99. In the year 1971, what is the difference between the % of value added in manufacturing in Iraq and % of value added in manufacturing in Tunisia?
Offer a very short reply. -8.21. In the year 1971, what is the difference between the % of value added in manufacturing in Philippines and % of value added in manufacturing in Tunisia?
Your answer should be compact. -1.22. In the year 1972, what is the difference between the % of value added in manufacturing of Bangladesh and % of value added in manufacturing of Iraq?
Offer a terse response. 8.06. In the year 1972, what is the difference between the % of value added in manufacturing of Bangladesh and % of value added in manufacturing of Philippines?
Your response must be concise. 1.79. In the year 1972, what is the difference between the % of value added in manufacturing in Bangladesh and % of value added in manufacturing in Tunisia?
Provide a succinct answer. -0.14. In the year 1972, what is the difference between the % of value added in manufacturing of Iraq and % of value added in manufacturing of Philippines?
Give a very brief answer. -6.27. In the year 1972, what is the difference between the % of value added in manufacturing in Iraq and % of value added in manufacturing in Tunisia?
Provide a succinct answer. -8.2. In the year 1972, what is the difference between the % of value added in manufacturing of Philippines and % of value added in manufacturing of Tunisia?
Provide a succinct answer. -1.93. In the year 1973, what is the difference between the % of value added in manufacturing of Bangladesh and % of value added in manufacturing of Iraq?
Offer a terse response. 1.81. In the year 1973, what is the difference between the % of value added in manufacturing in Bangladesh and % of value added in manufacturing in Philippines?
Ensure brevity in your answer.  0.01. In the year 1973, what is the difference between the % of value added in manufacturing of Bangladesh and % of value added in manufacturing of Tunisia?
Your answer should be compact. -5.29. In the year 1973, what is the difference between the % of value added in manufacturing of Iraq and % of value added in manufacturing of Philippines?
Offer a very short reply. -1.8. In the year 1973, what is the difference between the % of value added in manufacturing of Iraq and % of value added in manufacturing of Tunisia?
Give a very brief answer. -7.1. In the year 1973, what is the difference between the % of value added in manufacturing of Philippines and % of value added in manufacturing of Tunisia?
Keep it short and to the point. -5.3. In the year 1974, what is the difference between the % of value added in manufacturing in Bangladesh and % of value added in manufacturing in Iraq?
Provide a short and direct response. 3.86. In the year 1974, what is the difference between the % of value added in manufacturing in Bangladesh and % of value added in manufacturing in Philippines?
Make the answer very short. 2.55. In the year 1974, what is the difference between the % of value added in manufacturing in Bangladesh and % of value added in manufacturing in Tunisia?
Your response must be concise. -11.36. In the year 1974, what is the difference between the % of value added in manufacturing in Iraq and % of value added in manufacturing in Philippines?
Make the answer very short. -1.31. In the year 1974, what is the difference between the % of value added in manufacturing of Iraq and % of value added in manufacturing of Tunisia?
Make the answer very short. -15.23. In the year 1974, what is the difference between the % of value added in manufacturing in Philippines and % of value added in manufacturing in Tunisia?
Offer a very short reply. -13.92. In the year 1975, what is the difference between the % of value added in manufacturing in Bangladesh and % of value added in manufacturing in Iraq?
Your answer should be very brief. 4.33. In the year 1975, what is the difference between the % of value added in manufacturing of Bangladesh and % of value added in manufacturing of Philippines?
Make the answer very short. 4.46. In the year 1975, what is the difference between the % of value added in manufacturing of Bangladesh and % of value added in manufacturing of Tunisia?
Your answer should be compact. -1.59. In the year 1975, what is the difference between the % of value added in manufacturing in Iraq and % of value added in manufacturing in Philippines?
Provide a succinct answer. 0.14. In the year 1975, what is the difference between the % of value added in manufacturing of Iraq and % of value added in manufacturing of Tunisia?
Keep it short and to the point. -5.91. In the year 1975, what is the difference between the % of value added in manufacturing in Philippines and % of value added in manufacturing in Tunisia?
Provide a succinct answer. -6.05. In the year 1976, what is the difference between the % of value added in manufacturing of Bangladesh and % of value added in manufacturing of Iraq?
Keep it short and to the point. 3.57. In the year 1976, what is the difference between the % of value added in manufacturing in Bangladesh and % of value added in manufacturing in Philippines?
Offer a very short reply. 2. In the year 1976, what is the difference between the % of value added in manufacturing of Bangladesh and % of value added in manufacturing of Tunisia?
Offer a terse response. 6.53. In the year 1976, what is the difference between the % of value added in manufacturing of Iraq and % of value added in manufacturing of Philippines?
Offer a very short reply. -1.57. In the year 1976, what is the difference between the % of value added in manufacturing of Iraq and % of value added in manufacturing of Tunisia?
Your response must be concise. 2.96. In the year 1976, what is the difference between the % of value added in manufacturing in Philippines and % of value added in manufacturing in Tunisia?
Offer a terse response. 4.53. In the year 1977, what is the difference between the % of value added in manufacturing of Bangladesh and % of value added in manufacturing of Iraq?
Give a very brief answer. 1.79. In the year 1977, what is the difference between the % of value added in manufacturing of Bangladesh and % of value added in manufacturing of Philippines?
Ensure brevity in your answer.  -0.35. In the year 1977, what is the difference between the % of value added in manufacturing of Bangladesh and % of value added in manufacturing of Tunisia?
Offer a very short reply. 2.66. In the year 1977, what is the difference between the % of value added in manufacturing of Iraq and % of value added in manufacturing of Philippines?
Your answer should be compact. -2.13. In the year 1977, what is the difference between the % of value added in manufacturing of Iraq and % of value added in manufacturing of Tunisia?
Ensure brevity in your answer.  0.87. In the year 1977, what is the difference between the % of value added in manufacturing in Philippines and % of value added in manufacturing in Tunisia?
Your response must be concise. 3. What is the ratio of the % of value added in manufacturing in Bangladesh in 1971 to that in 1972?
Offer a terse response. 0.8. What is the ratio of the % of value added in manufacturing of Iraq in 1971 to that in 1972?
Offer a very short reply. 0.86. What is the ratio of the % of value added in manufacturing of Philippines in 1971 to that in 1972?
Your answer should be very brief. 0.98. What is the ratio of the % of value added in manufacturing in Tunisia in 1971 to that in 1972?
Make the answer very short. 0.93. What is the ratio of the % of value added in manufacturing in Bangladesh in 1971 to that in 1973?
Keep it short and to the point. 1.01. What is the ratio of the % of value added in manufacturing in Iraq in 1971 to that in 1973?
Provide a short and direct response. 0.61. What is the ratio of the % of value added in manufacturing of Philippines in 1971 to that in 1973?
Your answer should be compact. 1.1. What is the ratio of the % of value added in manufacturing of Tunisia in 1971 to that in 1973?
Provide a succinct answer. 0.83. What is the ratio of the % of value added in manufacturing in Bangladesh in 1971 to that in 1974?
Ensure brevity in your answer.  0.96. What is the ratio of the % of value added in manufacturing of Iraq in 1971 to that in 1974?
Your answer should be very brief. 0.7. What is the ratio of the % of value added in manufacturing in Philippines in 1971 to that in 1974?
Give a very brief answer. 1.31. What is the ratio of the % of value added in manufacturing in Tunisia in 1971 to that in 1974?
Your answer should be compact. 0.6. What is the ratio of the % of value added in manufacturing in Bangladesh in 1971 to that in 1975?
Provide a succinct answer. 0.91. What is the ratio of the % of value added in manufacturing in Iraq in 1971 to that in 1975?
Ensure brevity in your answer.  0.68. What is the ratio of the % of value added in manufacturing in Philippines in 1971 to that in 1975?
Your answer should be compact. 1.49. What is the ratio of the % of value added in manufacturing in Tunisia in 1971 to that in 1975?
Offer a terse response. 0.96. What is the ratio of the % of value added in manufacturing in Bangladesh in 1971 to that in 1976?
Provide a short and direct response. 0.78. What is the ratio of the % of value added in manufacturing of Iraq in 1971 to that in 1976?
Provide a succinct answer. 0.51. What is the ratio of the % of value added in manufacturing in Philippines in 1971 to that in 1976?
Offer a terse response. 0.97. What is the ratio of the % of value added in manufacturing in Tunisia in 1971 to that in 1976?
Offer a very short reply. 1.59. What is the ratio of the % of value added in manufacturing of Bangladesh in 1971 to that in 1977?
Your response must be concise. 0.92. What is the ratio of the % of value added in manufacturing of Iraq in 1971 to that in 1977?
Offer a terse response. 0.54. What is the ratio of the % of value added in manufacturing in Philippines in 1971 to that in 1977?
Your response must be concise. 0.97. What is the ratio of the % of value added in manufacturing of Tunisia in 1971 to that in 1977?
Ensure brevity in your answer.  1.36. What is the ratio of the % of value added in manufacturing of Bangladesh in 1972 to that in 1973?
Your answer should be compact. 1.27. What is the ratio of the % of value added in manufacturing in Iraq in 1972 to that in 1973?
Keep it short and to the point. 0.71. What is the ratio of the % of value added in manufacturing of Philippines in 1972 to that in 1973?
Provide a short and direct response. 1.13. What is the ratio of the % of value added in manufacturing of Tunisia in 1972 to that in 1973?
Your answer should be compact. 0.89. What is the ratio of the % of value added in manufacturing in Bangladesh in 1972 to that in 1974?
Ensure brevity in your answer.  1.21. What is the ratio of the % of value added in manufacturing in Iraq in 1972 to that in 1974?
Ensure brevity in your answer.  0.82. What is the ratio of the % of value added in manufacturing in Philippines in 1972 to that in 1974?
Ensure brevity in your answer.  1.34. What is the ratio of the % of value added in manufacturing of Tunisia in 1972 to that in 1974?
Provide a short and direct response. 0.64. What is the ratio of the % of value added in manufacturing of Bangladesh in 1972 to that in 1975?
Your answer should be very brief. 1.14. What is the ratio of the % of value added in manufacturing in Iraq in 1972 to that in 1975?
Provide a succinct answer. 0.8. What is the ratio of the % of value added in manufacturing in Philippines in 1972 to that in 1975?
Ensure brevity in your answer.  1.52. What is the ratio of the % of value added in manufacturing in Tunisia in 1972 to that in 1975?
Give a very brief answer. 1.03. What is the ratio of the % of value added in manufacturing of Bangladesh in 1972 to that in 1976?
Make the answer very short. 0.98. What is the ratio of the % of value added in manufacturing in Iraq in 1972 to that in 1976?
Ensure brevity in your answer.  0.6. What is the ratio of the % of value added in manufacturing in Philippines in 1972 to that in 1976?
Your answer should be very brief. 0.99. What is the ratio of the % of value added in manufacturing of Tunisia in 1972 to that in 1976?
Your answer should be compact. 1.7. What is the ratio of the % of value added in manufacturing of Bangladesh in 1972 to that in 1977?
Offer a terse response. 1.15. What is the ratio of the % of value added in manufacturing of Iraq in 1972 to that in 1977?
Provide a short and direct response. 0.63. What is the ratio of the % of value added in manufacturing in Philippines in 1972 to that in 1977?
Your response must be concise. 0.99. What is the ratio of the % of value added in manufacturing in Tunisia in 1972 to that in 1977?
Make the answer very short. 1.46. What is the ratio of the % of value added in manufacturing in Bangladesh in 1973 to that in 1974?
Give a very brief answer. 0.95. What is the ratio of the % of value added in manufacturing in Iraq in 1973 to that in 1974?
Keep it short and to the point. 1.16. What is the ratio of the % of value added in manufacturing of Philippines in 1973 to that in 1974?
Your answer should be very brief. 1.19. What is the ratio of the % of value added in manufacturing of Tunisia in 1973 to that in 1974?
Keep it short and to the point. 0.72. What is the ratio of the % of value added in manufacturing in Bangladesh in 1973 to that in 1975?
Give a very brief answer. 0.9. What is the ratio of the % of value added in manufacturing of Iraq in 1973 to that in 1975?
Ensure brevity in your answer.  1.13. What is the ratio of the % of value added in manufacturing in Philippines in 1973 to that in 1975?
Provide a short and direct response. 1.35. What is the ratio of the % of value added in manufacturing of Tunisia in 1973 to that in 1975?
Your answer should be very brief. 1.16. What is the ratio of the % of value added in manufacturing in Bangladesh in 1973 to that in 1976?
Offer a very short reply. 0.77. What is the ratio of the % of value added in manufacturing of Iraq in 1973 to that in 1976?
Offer a very short reply. 0.84. What is the ratio of the % of value added in manufacturing of Philippines in 1973 to that in 1976?
Provide a short and direct response. 0.88. What is the ratio of the % of value added in manufacturing of Tunisia in 1973 to that in 1976?
Make the answer very short. 1.91. What is the ratio of the % of value added in manufacturing in Bangladesh in 1973 to that in 1977?
Provide a succinct answer. 0.9. What is the ratio of the % of value added in manufacturing in Iraq in 1973 to that in 1977?
Provide a short and direct response. 0.89. What is the ratio of the % of value added in manufacturing in Philippines in 1973 to that in 1977?
Offer a terse response. 0.88. What is the ratio of the % of value added in manufacturing in Tunisia in 1973 to that in 1977?
Keep it short and to the point. 1.63. What is the ratio of the % of value added in manufacturing of Bangladesh in 1974 to that in 1975?
Your response must be concise. 0.95. What is the ratio of the % of value added in manufacturing of Iraq in 1974 to that in 1975?
Offer a very short reply. 0.97. What is the ratio of the % of value added in manufacturing in Philippines in 1974 to that in 1975?
Your response must be concise. 1.14. What is the ratio of the % of value added in manufacturing in Tunisia in 1974 to that in 1975?
Ensure brevity in your answer.  1.61. What is the ratio of the % of value added in manufacturing in Bangladesh in 1974 to that in 1976?
Your response must be concise. 0.81. What is the ratio of the % of value added in manufacturing of Iraq in 1974 to that in 1976?
Provide a short and direct response. 0.73. What is the ratio of the % of value added in manufacturing in Philippines in 1974 to that in 1976?
Make the answer very short. 0.74. What is the ratio of the % of value added in manufacturing of Tunisia in 1974 to that in 1976?
Make the answer very short. 2.65. What is the ratio of the % of value added in manufacturing of Bangladesh in 1974 to that in 1977?
Offer a very short reply. 0.95. What is the ratio of the % of value added in manufacturing in Iraq in 1974 to that in 1977?
Provide a succinct answer. 0.76. What is the ratio of the % of value added in manufacturing of Philippines in 1974 to that in 1977?
Make the answer very short. 0.74. What is the ratio of the % of value added in manufacturing of Tunisia in 1974 to that in 1977?
Offer a very short reply. 2.27. What is the ratio of the % of value added in manufacturing in Bangladesh in 1975 to that in 1976?
Provide a short and direct response. 0.85. What is the ratio of the % of value added in manufacturing of Iraq in 1975 to that in 1976?
Provide a short and direct response. 0.75. What is the ratio of the % of value added in manufacturing of Philippines in 1975 to that in 1976?
Your response must be concise. 0.65. What is the ratio of the % of value added in manufacturing in Tunisia in 1975 to that in 1976?
Give a very brief answer. 1.64. What is the ratio of the % of value added in manufacturing in Bangladesh in 1975 to that in 1977?
Offer a terse response. 1.01. What is the ratio of the % of value added in manufacturing in Iraq in 1975 to that in 1977?
Make the answer very short. 0.78. What is the ratio of the % of value added in manufacturing in Philippines in 1975 to that in 1977?
Your answer should be compact. 0.65. What is the ratio of the % of value added in manufacturing of Tunisia in 1975 to that in 1977?
Your response must be concise. 1.41. What is the ratio of the % of value added in manufacturing of Bangladesh in 1976 to that in 1977?
Provide a short and direct response. 1.18. What is the ratio of the % of value added in manufacturing of Iraq in 1976 to that in 1977?
Your answer should be compact. 1.05. What is the ratio of the % of value added in manufacturing in Tunisia in 1976 to that in 1977?
Provide a succinct answer. 0.86. What is the difference between the highest and the second highest % of value added in manufacturing in Bangladesh?
Your answer should be very brief. 0.37. What is the difference between the highest and the second highest % of value added in manufacturing in Iraq?
Provide a succinct answer. 0.6. What is the difference between the highest and the second highest % of value added in manufacturing in Philippines?
Offer a terse response. 0.03. What is the difference between the highest and the second highest % of value added in manufacturing of Tunisia?
Your answer should be compact. 6.72. What is the difference between the highest and the lowest % of value added in manufacturing in Bangladesh?
Provide a short and direct response. 3.64. What is the difference between the highest and the lowest % of value added in manufacturing of Iraq?
Keep it short and to the point. 5.87. What is the difference between the highest and the lowest % of value added in manufacturing in Philippines?
Give a very brief answer. 4.75. What is the difference between the highest and the lowest % of value added in manufacturing in Tunisia?
Ensure brevity in your answer.  14.9. 